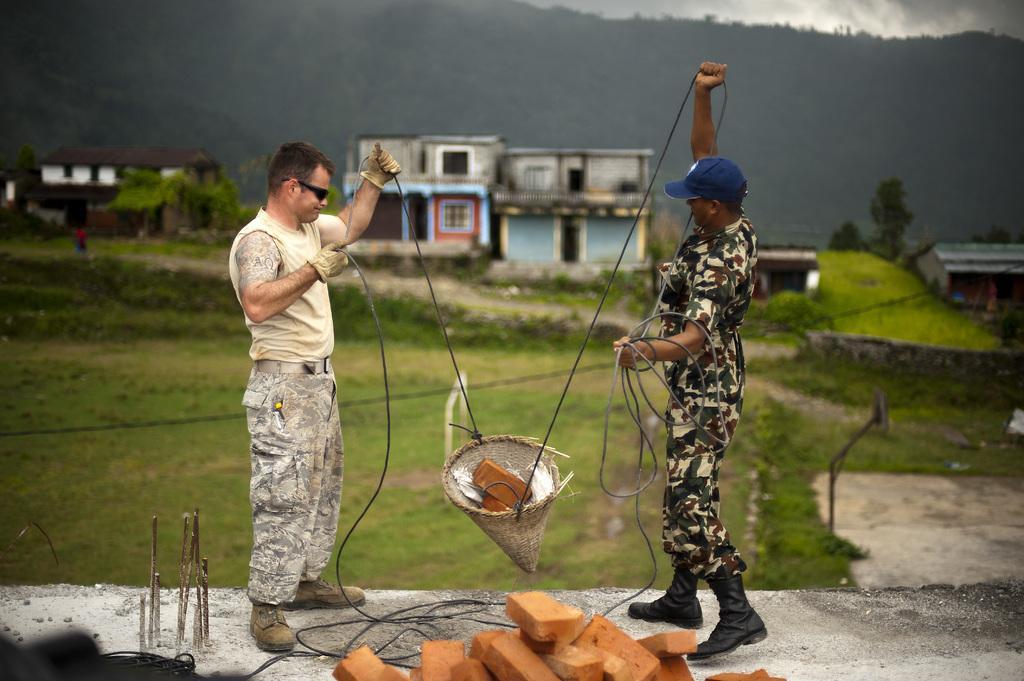Describe this image in one or two sentences. In this image I can see two persons are standing on the road and holding a rope in hand and bricks. In the background I can see grass, plants, trees, houses and mountains. On the top right I can see the sky. This image is taken may be near the mountains. 